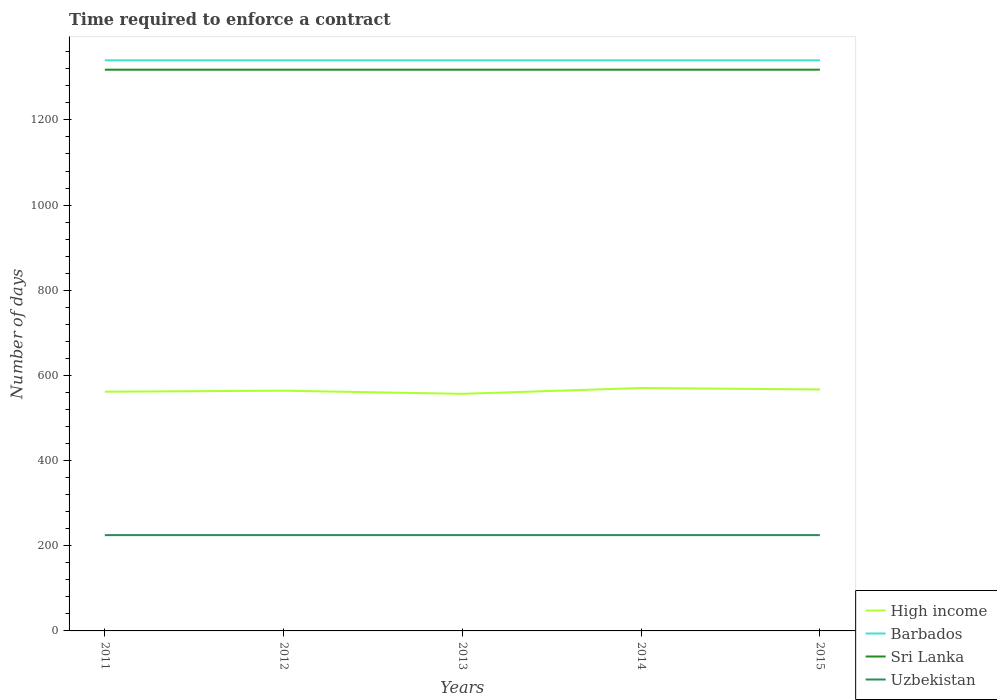How many different coloured lines are there?
Provide a succinct answer. 4. Across all years, what is the maximum number of days required to enforce a contract in Sri Lanka?
Your response must be concise. 1318. What is the total number of days required to enforce a contract in Sri Lanka in the graph?
Make the answer very short. 0. What is the difference between the highest and the second highest number of days required to enforce a contract in High income?
Provide a succinct answer. 13.67. Is the number of days required to enforce a contract in Sri Lanka strictly greater than the number of days required to enforce a contract in Barbados over the years?
Give a very brief answer. Yes. How many lines are there?
Ensure brevity in your answer.  4. How are the legend labels stacked?
Provide a short and direct response. Vertical. What is the title of the graph?
Your answer should be compact. Time required to enforce a contract. Does "South Asia" appear as one of the legend labels in the graph?
Your answer should be very brief. No. What is the label or title of the X-axis?
Provide a short and direct response. Years. What is the label or title of the Y-axis?
Your answer should be very brief. Number of days. What is the Number of days in High income in 2011?
Ensure brevity in your answer.  561.82. What is the Number of days of Barbados in 2011?
Ensure brevity in your answer.  1340. What is the Number of days of Sri Lanka in 2011?
Your answer should be very brief. 1318. What is the Number of days of Uzbekistan in 2011?
Ensure brevity in your answer.  225. What is the Number of days in High income in 2012?
Your response must be concise. 564.18. What is the Number of days of Barbados in 2012?
Your response must be concise. 1340. What is the Number of days in Sri Lanka in 2012?
Make the answer very short. 1318. What is the Number of days of Uzbekistan in 2012?
Your answer should be compact. 225. What is the Number of days in High income in 2013?
Your answer should be compact. 556.78. What is the Number of days of Barbados in 2013?
Offer a terse response. 1340. What is the Number of days of Sri Lanka in 2013?
Provide a succinct answer. 1318. What is the Number of days in Uzbekistan in 2013?
Keep it short and to the point. 225. What is the Number of days of High income in 2014?
Your response must be concise. 570.45. What is the Number of days in Barbados in 2014?
Your answer should be compact. 1340. What is the Number of days of Sri Lanka in 2014?
Provide a succinct answer. 1318. What is the Number of days in Uzbekistan in 2014?
Your response must be concise. 225. What is the Number of days in High income in 2015?
Provide a succinct answer. 567.05. What is the Number of days in Barbados in 2015?
Make the answer very short. 1340. What is the Number of days of Sri Lanka in 2015?
Keep it short and to the point. 1318. What is the Number of days of Uzbekistan in 2015?
Your answer should be very brief. 225. Across all years, what is the maximum Number of days in High income?
Ensure brevity in your answer.  570.45. Across all years, what is the maximum Number of days of Barbados?
Your response must be concise. 1340. Across all years, what is the maximum Number of days in Sri Lanka?
Give a very brief answer. 1318. Across all years, what is the maximum Number of days of Uzbekistan?
Keep it short and to the point. 225. Across all years, what is the minimum Number of days in High income?
Your response must be concise. 556.78. Across all years, what is the minimum Number of days in Barbados?
Give a very brief answer. 1340. Across all years, what is the minimum Number of days in Sri Lanka?
Offer a terse response. 1318. Across all years, what is the minimum Number of days in Uzbekistan?
Provide a succinct answer. 225. What is the total Number of days in High income in the graph?
Offer a terse response. 2820.28. What is the total Number of days of Barbados in the graph?
Offer a very short reply. 6700. What is the total Number of days in Sri Lanka in the graph?
Give a very brief answer. 6590. What is the total Number of days in Uzbekistan in the graph?
Your answer should be very brief. 1125. What is the difference between the Number of days in High income in 2011 and that in 2012?
Offer a very short reply. -2.35. What is the difference between the Number of days of Barbados in 2011 and that in 2012?
Offer a terse response. 0. What is the difference between the Number of days in Uzbekistan in 2011 and that in 2012?
Ensure brevity in your answer.  0. What is the difference between the Number of days in High income in 2011 and that in 2013?
Your response must be concise. 5.04. What is the difference between the Number of days in Uzbekistan in 2011 and that in 2013?
Provide a short and direct response. 0. What is the difference between the Number of days of High income in 2011 and that in 2014?
Make the answer very short. -8.63. What is the difference between the Number of days of Uzbekistan in 2011 and that in 2014?
Offer a terse response. 0. What is the difference between the Number of days of High income in 2011 and that in 2015?
Make the answer very short. -5.23. What is the difference between the Number of days of Uzbekistan in 2011 and that in 2015?
Ensure brevity in your answer.  0. What is the difference between the Number of days in High income in 2012 and that in 2013?
Offer a very short reply. 7.39. What is the difference between the Number of days in Sri Lanka in 2012 and that in 2013?
Your answer should be compact. 0. What is the difference between the Number of days in High income in 2012 and that in 2014?
Your answer should be very brief. -6.27. What is the difference between the Number of days of Barbados in 2012 and that in 2014?
Give a very brief answer. 0. What is the difference between the Number of days of Sri Lanka in 2012 and that in 2014?
Your response must be concise. 0. What is the difference between the Number of days in Uzbekistan in 2012 and that in 2014?
Your answer should be compact. 0. What is the difference between the Number of days in High income in 2012 and that in 2015?
Your answer should be compact. -2.87. What is the difference between the Number of days in High income in 2013 and that in 2014?
Provide a short and direct response. -13.67. What is the difference between the Number of days of Barbados in 2013 and that in 2014?
Provide a short and direct response. 0. What is the difference between the Number of days of High income in 2013 and that in 2015?
Provide a succinct answer. -10.27. What is the difference between the Number of days in Sri Lanka in 2013 and that in 2015?
Give a very brief answer. 0. What is the difference between the Number of days of Uzbekistan in 2013 and that in 2015?
Make the answer very short. 0. What is the difference between the Number of days of Sri Lanka in 2014 and that in 2015?
Provide a short and direct response. 0. What is the difference between the Number of days in Uzbekistan in 2014 and that in 2015?
Your answer should be very brief. 0. What is the difference between the Number of days in High income in 2011 and the Number of days in Barbados in 2012?
Your answer should be very brief. -778.18. What is the difference between the Number of days in High income in 2011 and the Number of days in Sri Lanka in 2012?
Your response must be concise. -756.18. What is the difference between the Number of days in High income in 2011 and the Number of days in Uzbekistan in 2012?
Keep it short and to the point. 336.82. What is the difference between the Number of days of Barbados in 2011 and the Number of days of Sri Lanka in 2012?
Your answer should be compact. 22. What is the difference between the Number of days of Barbados in 2011 and the Number of days of Uzbekistan in 2012?
Make the answer very short. 1115. What is the difference between the Number of days in Sri Lanka in 2011 and the Number of days in Uzbekistan in 2012?
Ensure brevity in your answer.  1093. What is the difference between the Number of days of High income in 2011 and the Number of days of Barbados in 2013?
Give a very brief answer. -778.18. What is the difference between the Number of days of High income in 2011 and the Number of days of Sri Lanka in 2013?
Your answer should be very brief. -756.18. What is the difference between the Number of days of High income in 2011 and the Number of days of Uzbekistan in 2013?
Offer a terse response. 336.82. What is the difference between the Number of days of Barbados in 2011 and the Number of days of Sri Lanka in 2013?
Your answer should be compact. 22. What is the difference between the Number of days in Barbados in 2011 and the Number of days in Uzbekistan in 2013?
Ensure brevity in your answer.  1115. What is the difference between the Number of days of Sri Lanka in 2011 and the Number of days of Uzbekistan in 2013?
Make the answer very short. 1093. What is the difference between the Number of days of High income in 2011 and the Number of days of Barbados in 2014?
Keep it short and to the point. -778.18. What is the difference between the Number of days of High income in 2011 and the Number of days of Sri Lanka in 2014?
Provide a succinct answer. -756.18. What is the difference between the Number of days in High income in 2011 and the Number of days in Uzbekistan in 2014?
Your answer should be compact. 336.82. What is the difference between the Number of days in Barbados in 2011 and the Number of days in Sri Lanka in 2014?
Make the answer very short. 22. What is the difference between the Number of days of Barbados in 2011 and the Number of days of Uzbekistan in 2014?
Make the answer very short. 1115. What is the difference between the Number of days in Sri Lanka in 2011 and the Number of days in Uzbekistan in 2014?
Your response must be concise. 1093. What is the difference between the Number of days in High income in 2011 and the Number of days in Barbados in 2015?
Provide a succinct answer. -778.18. What is the difference between the Number of days of High income in 2011 and the Number of days of Sri Lanka in 2015?
Give a very brief answer. -756.18. What is the difference between the Number of days in High income in 2011 and the Number of days in Uzbekistan in 2015?
Offer a terse response. 336.82. What is the difference between the Number of days of Barbados in 2011 and the Number of days of Uzbekistan in 2015?
Make the answer very short. 1115. What is the difference between the Number of days in Sri Lanka in 2011 and the Number of days in Uzbekistan in 2015?
Your answer should be compact. 1093. What is the difference between the Number of days of High income in 2012 and the Number of days of Barbados in 2013?
Your response must be concise. -775.82. What is the difference between the Number of days in High income in 2012 and the Number of days in Sri Lanka in 2013?
Your answer should be very brief. -753.82. What is the difference between the Number of days in High income in 2012 and the Number of days in Uzbekistan in 2013?
Your response must be concise. 339.18. What is the difference between the Number of days in Barbados in 2012 and the Number of days in Uzbekistan in 2013?
Make the answer very short. 1115. What is the difference between the Number of days of Sri Lanka in 2012 and the Number of days of Uzbekistan in 2013?
Provide a short and direct response. 1093. What is the difference between the Number of days of High income in 2012 and the Number of days of Barbados in 2014?
Give a very brief answer. -775.82. What is the difference between the Number of days in High income in 2012 and the Number of days in Sri Lanka in 2014?
Provide a short and direct response. -753.82. What is the difference between the Number of days of High income in 2012 and the Number of days of Uzbekistan in 2014?
Give a very brief answer. 339.18. What is the difference between the Number of days of Barbados in 2012 and the Number of days of Sri Lanka in 2014?
Ensure brevity in your answer.  22. What is the difference between the Number of days of Barbados in 2012 and the Number of days of Uzbekistan in 2014?
Provide a short and direct response. 1115. What is the difference between the Number of days of Sri Lanka in 2012 and the Number of days of Uzbekistan in 2014?
Provide a short and direct response. 1093. What is the difference between the Number of days in High income in 2012 and the Number of days in Barbados in 2015?
Ensure brevity in your answer.  -775.82. What is the difference between the Number of days of High income in 2012 and the Number of days of Sri Lanka in 2015?
Your answer should be compact. -753.82. What is the difference between the Number of days of High income in 2012 and the Number of days of Uzbekistan in 2015?
Make the answer very short. 339.18. What is the difference between the Number of days in Barbados in 2012 and the Number of days in Uzbekistan in 2015?
Make the answer very short. 1115. What is the difference between the Number of days of Sri Lanka in 2012 and the Number of days of Uzbekistan in 2015?
Your answer should be very brief. 1093. What is the difference between the Number of days in High income in 2013 and the Number of days in Barbados in 2014?
Your answer should be compact. -783.22. What is the difference between the Number of days of High income in 2013 and the Number of days of Sri Lanka in 2014?
Make the answer very short. -761.22. What is the difference between the Number of days in High income in 2013 and the Number of days in Uzbekistan in 2014?
Offer a terse response. 331.78. What is the difference between the Number of days in Barbados in 2013 and the Number of days in Sri Lanka in 2014?
Provide a short and direct response. 22. What is the difference between the Number of days in Barbados in 2013 and the Number of days in Uzbekistan in 2014?
Your answer should be compact. 1115. What is the difference between the Number of days of Sri Lanka in 2013 and the Number of days of Uzbekistan in 2014?
Your answer should be very brief. 1093. What is the difference between the Number of days of High income in 2013 and the Number of days of Barbados in 2015?
Provide a short and direct response. -783.22. What is the difference between the Number of days of High income in 2013 and the Number of days of Sri Lanka in 2015?
Ensure brevity in your answer.  -761.22. What is the difference between the Number of days in High income in 2013 and the Number of days in Uzbekistan in 2015?
Keep it short and to the point. 331.78. What is the difference between the Number of days in Barbados in 2013 and the Number of days in Sri Lanka in 2015?
Give a very brief answer. 22. What is the difference between the Number of days of Barbados in 2013 and the Number of days of Uzbekistan in 2015?
Offer a very short reply. 1115. What is the difference between the Number of days of Sri Lanka in 2013 and the Number of days of Uzbekistan in 2015?
Ensure brevity in your answer.  1093. What is the difference between the Number of days of High income in 2014 and the Number of days of Barbados in 2015?
Make the answer very short. -769.55. What is the difference between the Number of days in High income in 2014 and the Number of days in Sri Lanka in 2015?
Provide a succinct answer. -747.55. What is the difference between the Number of days in High income in 2014 and the Number of days in Uzbekistan in 2015?
Keep it short and to the point. 345.45. What is the difference between the Number of days in Barbados in 2014 and the Number of days in Uzbekistan in 2015?
Your answer should be very brief. 1115. What is the difference between the Number of days in Sri Lanka in 2014 and the Number of days in Uzbekistan in 2015?
Offer a very short reply. 1093. What is the average Number of days of High income per year?
Provide a short and direct response. 564.06. What is the average Number of days in Barbados per year?
Give a very brief answer. 1340. What is the average Number of days in Sri Lanka per year?
Offer a terse response. 1318. What is the average Number of days in Uzbekistan per year?
Offer a very short reply. 225. In the year 2011, what is the difference between the Number of days of High income and Number of days of Barbados?
Offer a terse response. -778.18. In the year 2011, what is the difference between the Number of days of High income and Number of days of Sri Lanka?
Provide a short and direct response. -756.18. In the year 2011, what is the difference between the Number of days in High income and Number of days in Uzbekistan?
Provide a short and direct response. 336.82. In the year 2011, what is the difference between the Number of days of Barbados and Number of days of Sri Lanka?
Offer a very short reply. 22. In the year 2011, what is the difference between the Number of days in Barbados and Number of days in Uzbekistan?
Your answer should be very brief. 1115. In the year 2011, what is the difference between the Number of days of Sri Lanka and Number of days of Uzbekistan?
Make the answer very short. 1093. In the year 2012, what is the difference between the Number of days in High income and Number of days in Barbados?
Your answer should be compact. -775.82. In the year 2012, what is the difference between the Number of days in High income and Number of days in Sri Lanka?
Give a very brief answer. -753.82. In the year 2012, what is the difference between the Number of days of High income and Number of days of Uzbekistan?
Ensure brevity in your answer.  339.18. In the year 2012, what is the difference between the Number of days of Barbados and Number of days of Sri Lanka?
Your answer should be very brief. 22. In the year 2012, what is the difference between the Number of days of Barbados and Number of days of Uzbekistan?
Provide a succinct answer. 1115. In the year 2012, what is the difference between the Number of days in Sri Lanka and Number of days in Uzbekistan?
Your answer should be compact. 1093. In the year 2013, what is the difference between the Number of days of High income and Number of days of Barbados?
Your answer should be compact. -783.22. In the year 2013, what is the difference between the Number of days of High income and Number of days of Sri Lanka?
Your response must be concise. -761.22. In the year 2013, what is the difference between the Number of days of High income and Number of days of Uzbekistan?
Offer a very short reply. 331.78. In the year 2013, what is the difference between the Number of days of Barbados and Number of days of Sri Lanka?
Your response must be concise. 22. In the year 2013, what is the difference between the Number of days in Barbados and Number of days in Uzbekistan?
Your response must be concise. 1115. In the year 2013, what is the difference between the Number of days in Sri Lanka and Number of days in Uzbekistan?
Provide a short and direct response. 1093. In the year 2014, what is the difference between the Number of days in High income and Number of days in Barbados?
Offer a terse response. -769.55. In the year 2014, what is the difference between the Number of days in High income and Number of days in Sri Lanka?
Your answer should be very brief. -747.55. In the year 2014, what is the difference between the Number of days of High income and Number of days of Uzbekistan?
Ensure brevity in your answer.  345.45. In the year 2014, what is the difference between the Number of days in Barbados and Number of days in Uzbekistan?
Provide a short and direct response. 1115. In the year 2014, what is the difference between the Number of days of Sri Lanka and Number of days of Uzbekistan?
Provide a short and direct response. 1093. In the year 2015, what is the difference between the Number of days in High income and Number of days in Barbados?
Give a very brief answer. -772.95. In the year 2015, what is the difference between the Number of days in High income and Number of days in Sri Lanka?
Provide a short and direct response. -750.95. In the year 2015, what is the difference between the Number of days of High income and Number of days of Uzbekistan?
Your answer should be compact. 342.05. In the year 2015, what is the difference between the Number of days in Barbados and Number of days in Sri Lanka?
Keep it short and to the point. 22. In the year 2015, what is the difference between the Number of days of Barbados and Number of days of Uzbekistan?
Your response must be concise. 1115. In the year 2015, what is the difference between the Number of days of Sri Lanka and Number of days of Uzbekistan?
Provide a short and direct response. 1093. What is the ratio of the Number of days of High income in 2011 to that in 2012?
Provide a short and direct response. 1. What is the ratio of the Number of days of Sri Lanka in 2011 to that in 2012?
Give a very brief answer. 1. What is the ratio of the Number of days in Uzbekistan in 2011 to that in 2012?
Offer a terse response. 1. What is the ratio of the Number of days in Barbados in 2011 to that in 2013?
Offer a very short reply. 1. What is the ratio of the Number of days in Sri Lanka in 2011 to that in 2013?
Provide a short and direct response. 1. What is the ratio of the Number of days of Uzbekistan in 2011 to that in 2013?
Give a very brief answer. 1. What is the ratio of the Number of days of High income in 2011 to that in 2014?
Provide a short and direct response. 0.98. What is the ratio of the Number of days of Barbados in 2011 to that in 2014?
Your answer should be very brief. 1. What is the ratio of the Number of days of Barbados in 2011 to that in 2015?
Your answer should be very brief. 1. What is the ratio of the Number of days of High income in 2012 to that in 2013?
Offer a terse response. 1.01. What is the ratio of the Number of days in Barbados in 2012 to that in 2013?
Provide a short and direct response. 1. What is the ratio of the Number of days in Sri Lanka in 2012 to that in 2013?
Your response must be concise. 1. What is the ratio of the Number of days in High income in 2012 to that in 2014?
Keep it short and to the point. 0.99. What is the ratio of the Number of days of Barbados in 2012 to that in 2014?
Offer a terse response. 1. What is the ratio of the Number of days in Barbados in 2013 to that in 2014?
Your answer should be very brief. 1. What is the ratio of the Number of days in Sri Lanka in 2013 to that in 2014?
Offer a terse response. 1. What is the ratio of the Number of days of High income in 2013 to that in 2015?
Make the answer very short. 0.98. What is the ratio of the Number of days of Barbados in 2013 to that in 2015?
Make the answer very short. 1. What is the ratio of the Number of days in Uzbekistan in 2013 to that in 2015?
Your answer should be compact. 1. What is the ratio of the Number of days in Sri Lanka in 2014 to that in 2015?
Your answer should be very brief. 1. What is the difference between the highest and the second highest Number of days of Barbados?
Provide a short and direct response. 0. What is the difference between the highest and the second highest Number of days of Sri Lanka?
Make the answer very short. 0. What is the difference between the highest and the second highest Number of days in Uzbekistan?
Keep it short and to the point. 0. What is the difference between the highest and the lowest Number of days of High income?
Offer a terse response. 13.67. 